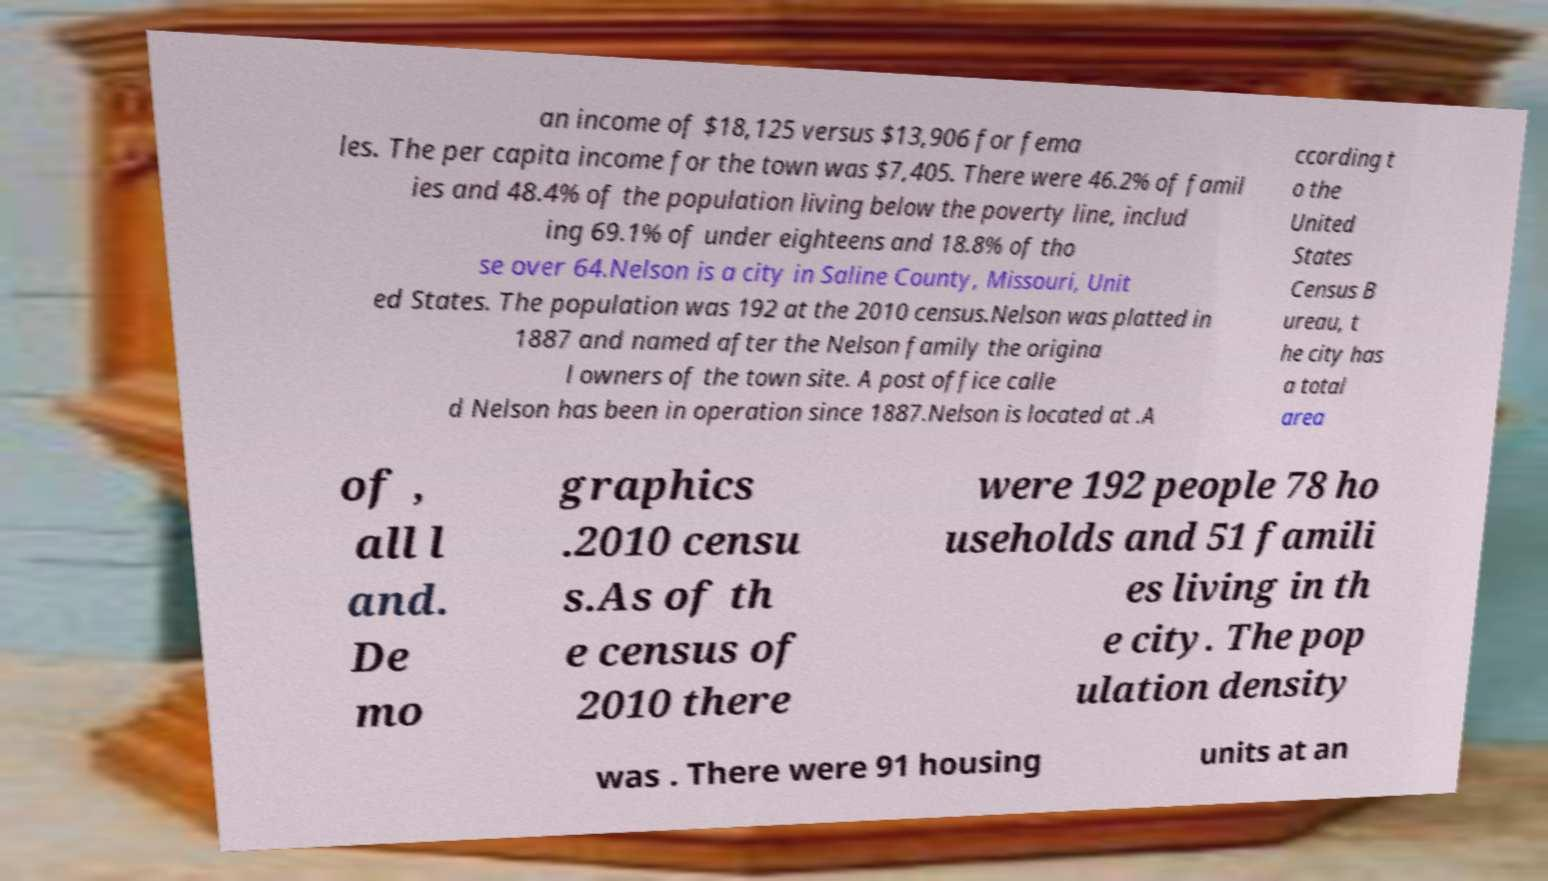Could you extract and type out the text from this image? an income of $18,125 versus $13,906 for fema les. The per capita income for the town was $7,405. There were 46.2% of famil ies and 48.4% of the population living below the poverty line, includ ing 69.1% of under eighteens and 18.8% of tho se over 64.Nelson is a city in Saline County, Missouri, Unit ed States. The population was 192 at the 2010 census.Nelson was platted in 1887 and named after the Nelson family the origina l owners of the town site. A post office calle d Nelson has been in operation since 1887.Nelson is located at .A ccording t o the United States Census B ureau, t he city has a total area of , all l and. De mo graphics .2010 censu s.As of th e census of 2010 there were 192 people 78 ho useholds and 51 famili es living in th e city. The pop ulation density was . There were 91 housing units at an 